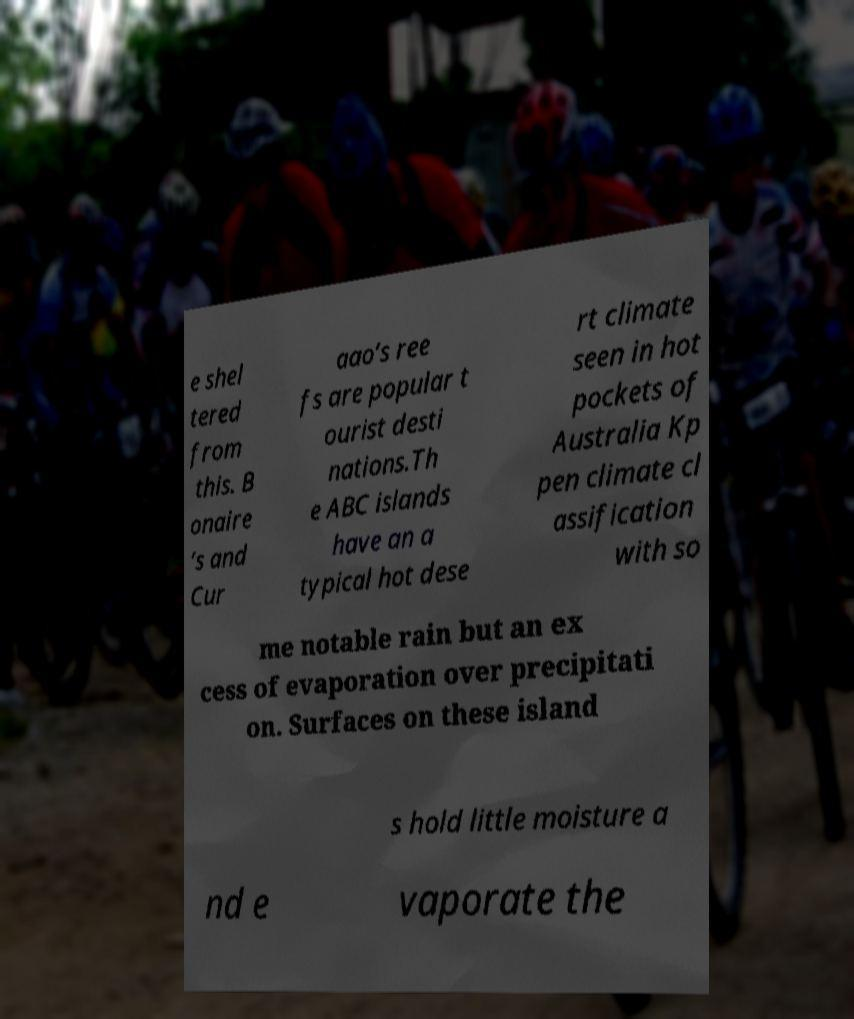Please read and relay the text visible in this image. What does it say? e shel tered from this. B onaire ’s and Cur aao’s ree fs are popular t ourist desti nations.Th e ABC islands have an a typical hot dese rt climate seen in hot pockets of Australia Kp pen climate cl assification with so me notable rain but an ex cess of evaporation over precipitati on. Surfaces on these island s hold little moisture a nd e vaporate the 